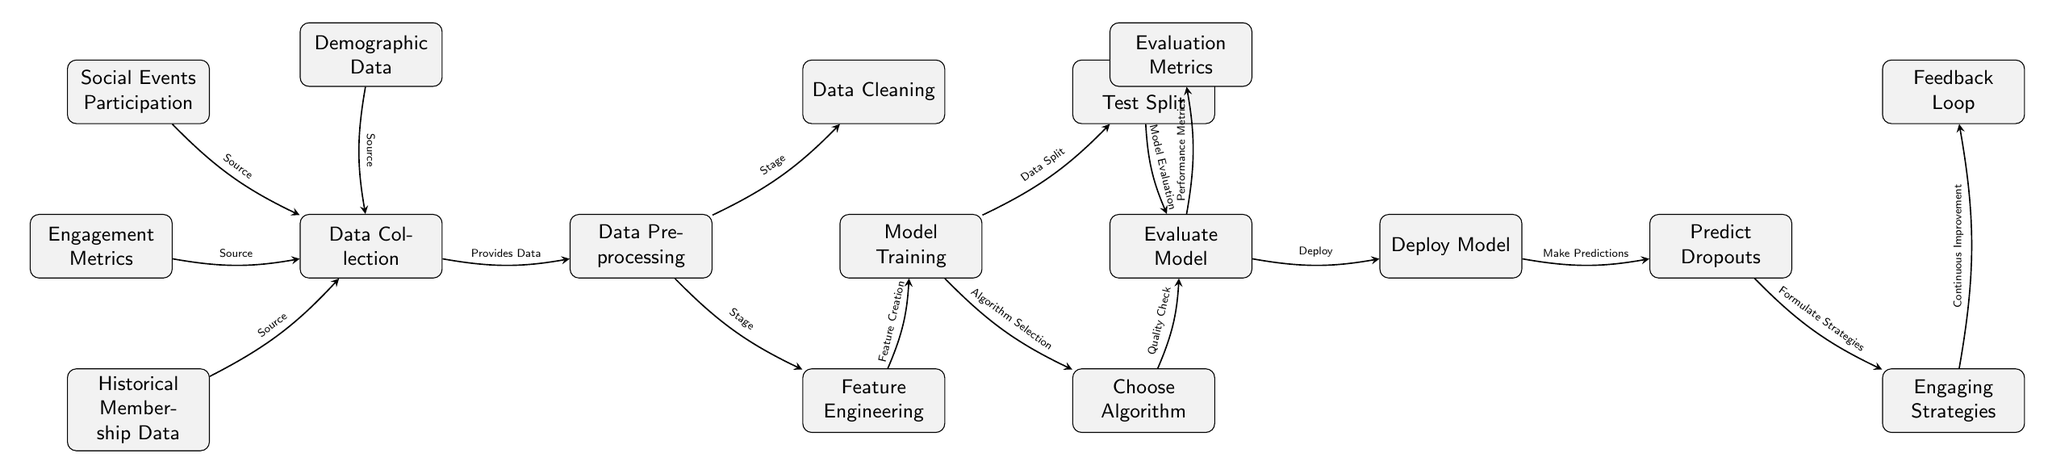What are the four sources of data collection? The diagram identifies four sources that contribute to data collection, which are historical membership data, engagement metrics, social events participation, and demographic data.
Answer: historical membership data, engagement metrics, social events participation, demographic data What is the first stage after data collection? Following the data collection, the next stage depicted in the diagram is data preprocessing. This node directly receives data from the data collection node.
Answer: data preprocessing How many nodes are involved in the model training phase? The model training phase encompasses three nodes: the model training node itself, train-test split, and choose algorithm. Therefore, a total of three nodes are involved in this phase.
Answer: three What is the function of the feedback loop? The feedback loop in the diagram serves as a mechanism for continuous improvement based on the engaging strategies that have been formulated. It connects back to the strategies node, indicating its role in refining approaches.
Answer: continuous improvement What is needed before model evaluation? In the workflow depicted in the diagram, both train-test split and choose algorithm must occur before the model evaluation can take place, as they provide essential inputs for proper evaluation of the model's performance.
Answer: train-test split and choose algorithm How does the data flow from data preprocessing to the next stage in the process? Data flows from data preprocessing to model training. After preprocessing, the data is passed to model training, which involves further steps like splitting the data and choosing an algorithm.
Answer: model training Which node leads to the prediction of dropouts? The node that leads to the prediction of dropouts is the deploy model node, as it connects directly to the predict dropouts node, indicating that deployment must occur to make predictions about membership dropout.
Answer: deploy model What crucial feedback component occurs after the engaging strategies? The diagram indicates that after engaging strategies, there is a feedback loop that represents the importance of continuous improvement based on the effectiveness of those strategies.
Answer: feedback loop 